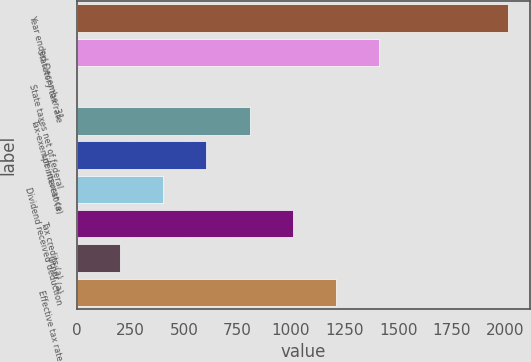Convert chart. <chart><loc_0><loc_0><loc_500><loc_500><bar_chart><fcel>Year ended December 31<fcel>Statutory tax rate<fcel>State taxes net of federal<fcel>Tax-exempt interest (a)<fcel>Life insurance<fcel>Dividend received deduction<fcel>Tax credits (a)<fcel>Other (a)<fcel>Effective tax rate<nl><fcel>2014<fcel>1410.16<fcel>1.2<fcel>806.32<fcel>605.04<fcel>403.76<fcel>1007.6<fcel>202.48<fcel>1208.88<nl></chart> 